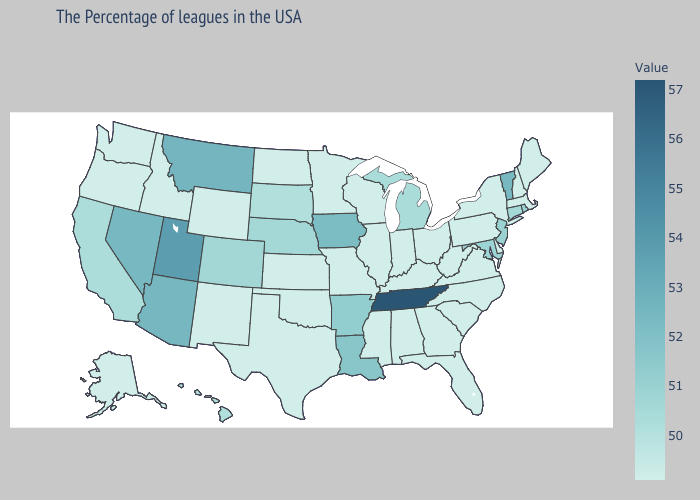Does Rhode Island have the highest value in the Northeast?
Be succinct. No. Is the legend a continuous bar?
Be succinct. Yes. Is the legend a continuous bar?
Answer briefly. Yes. Is the legend a continuous bar?
Give a very brief answer. Yes. Among the states that border Kentucky , which have the lowest value?
Quick response, please. Virginia, West Virginia, Ohio, Indiana, Illinois, Missouri. 